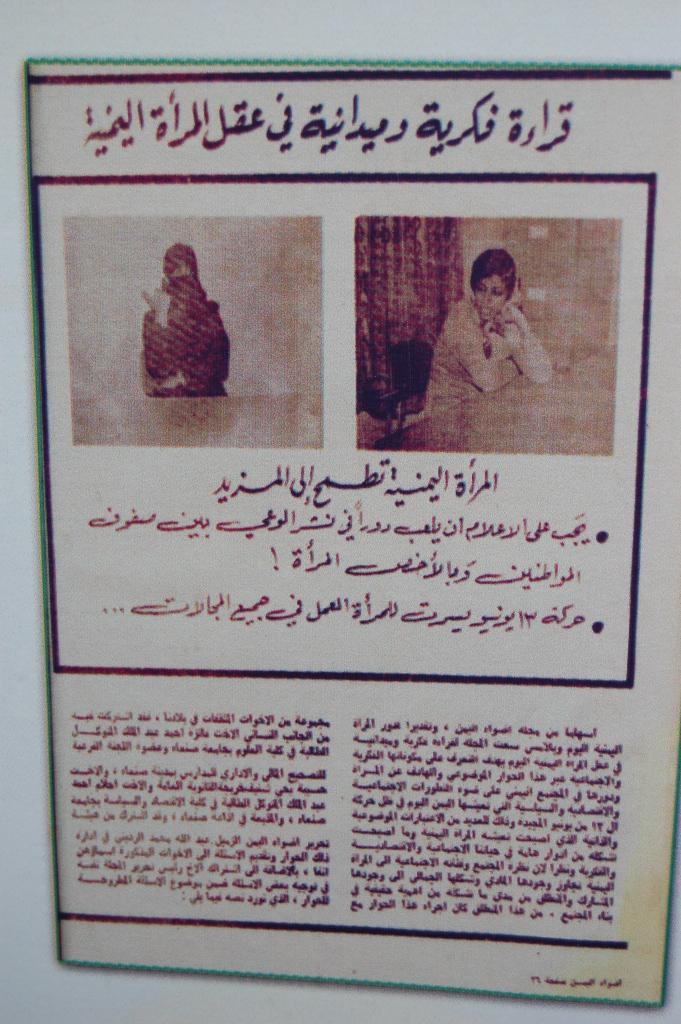Can you describe this image briefly? In this image I can see I can see a paper, in the paper I can see person images and, one person sitting in the chair in front of the table and a text visible. 